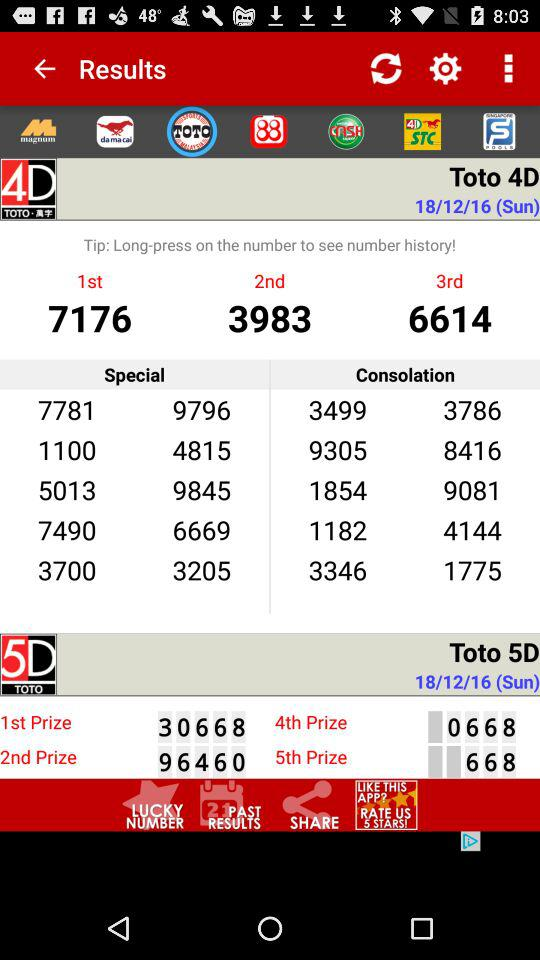What is the date of Toto 5D? The date is Sunday, December 18, 2016. 